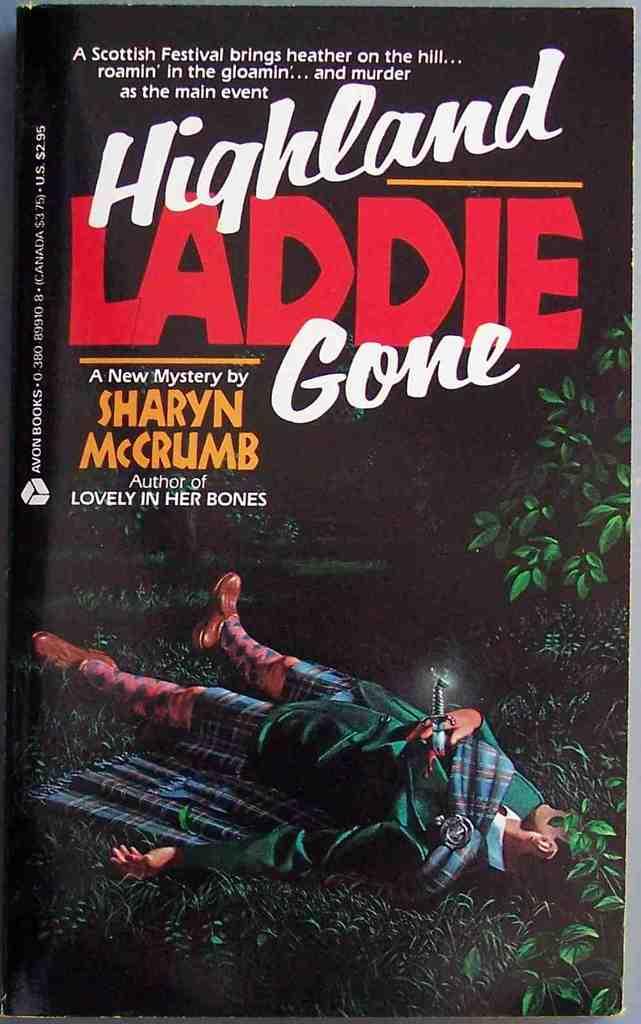How wrote the book?
Provide a succinct answer. Sharyn mccrumb. What is the title of the movie?
Your response must be concise. Highland laddie gone. 